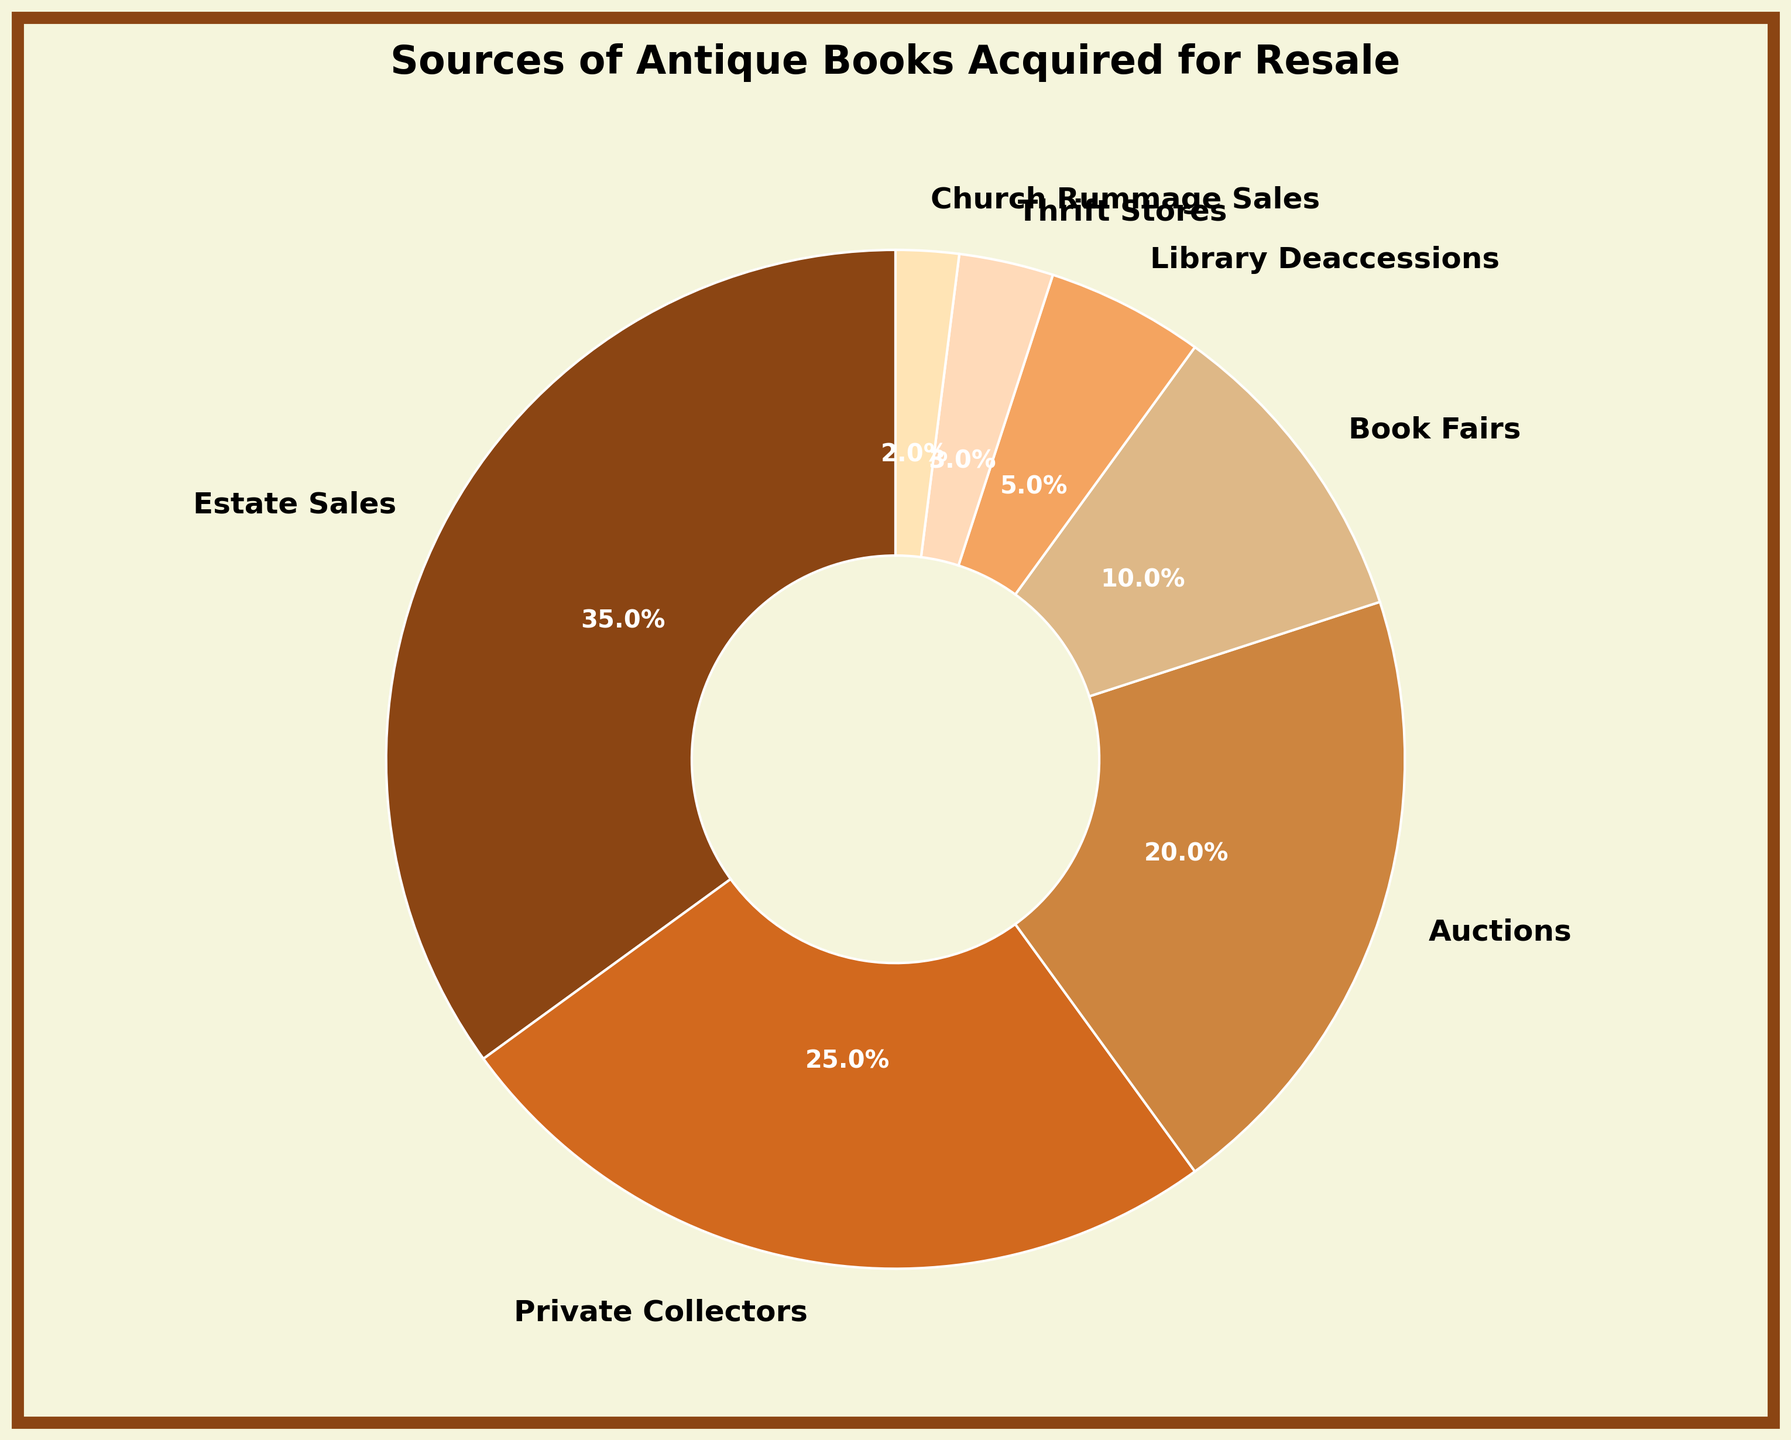What's the most common source for acquiring antique books? By looking at the pie chart, we see that "Estate Sales" have the largest segment, which means it is the most common source.
Answer: Estate Sales Which two sources contribute equally? Examining the pie chart reveals that both "Library Deaccessions" and "Thrift Stores" each have segments of equal size, representing 5% and 3%, respectively.
Answer: Thrift Stores, Church Rummage Sales Is the percentage of books from Auctions greater than from Private Collectors? The pie chart shows that "Auctions" contribute to 20% of the books, while "Private Collectors" contribute 25%. Since 20% is less than 25%, Auctions have a lower percentage.
Answer: No What's the combined percentage of books acquired from sources other than Estate Sales and Private Collectors? First, sum the percentages of all sources excluding "Estate Sales" (35%) and "Private Collectors" (25%). The remaining sources are 20% (Auctions) + 10% (Book Fairs) + 5% (Library Deaccessions) + 3% (Thrift Stores) + 2% (Church Rummage Sales), which is 40%.
Answer: 40% Do Book Fairs contribute more than 10% of the total antique books? The pie chart shows that "Book Fairs" contribute exactly 10%, which is not more than 10%.
Answer: No What's the total percentage of books acquired from sources with less than 10% each? Add the percentages of all sources that contribute less than 10%: Library Deaccessions (5%) + Thrift Stores (3%) + Church Rummage Sales (2%). This totals to 5% + 3% + 2% = 10%.
Answer: 10% Which source has the second largest segment in the pie chart? Observing the pie chart, "Private Collectors" have the second largest segment with 25%.
Answer: Private Collectors What is the visual color representation of Estate Sales? The color segment for "Estate Sales" is the first one in the custom color palette provided, which appears to be a dark brown color in the chart.
Answer: Dark Brown How does the percentage from Book Fairs compare to Library Deaccessions? From the pie chart, "Book Fairs" contribute 10%, while "Library Deaccessions" contribute 5%. Since 10% is double 5%, Book Fairs contribute twice as much as Library Deaccessions.
Answer: Twice as much What fraction of the total percentage does the least contributing source represent? The least contributing source is "Church Rummage Sales" with 2%. As a fraction of the total 100%, this is 2/100, which simplifies to 1/50.
Answer: 1/50 